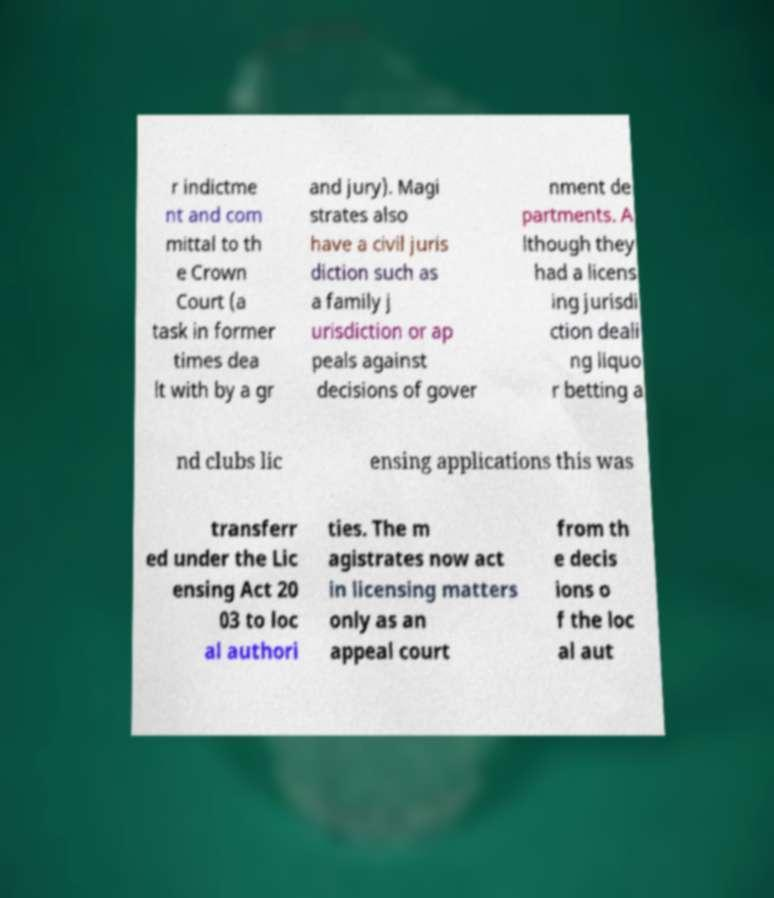Could you assist in decoding the text presented in this image and type it out clearly? r indictme nt and com mittal to th e Crown Court (a task in former times dea lt with by a gr and jury). Magi strates also have a civil juris diction such as a family j urisdiction or ap peals against decisions of gover nment de partments. A lthough they had a licens ing jurisdi ction deali ng liquo r betting a nd clubs lic ensing applications this was transferr ed under the Lic ensing Act 20 03 to loc al authori ties. The m agistrates now act in licensing matters only as an appeal court from th e decis ions o f the loc al aut 